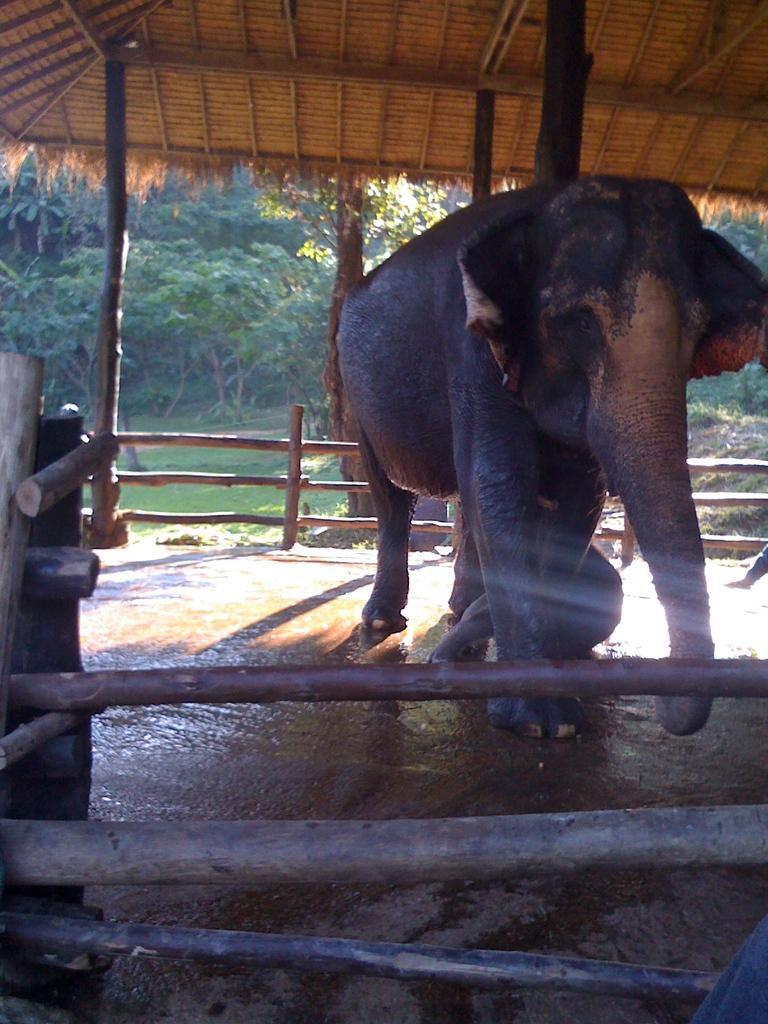What animal is on the ground in the image? There is an elephant on the ground in the image. What can be seen in the background of the image? There is a group of wood poles, a shed, a group of trees, and grass visible in the background of the image. What type of weather can be seen in the harbor in the image? There is no harbor or ocean present in the image, so it is not possible to determine the weather conditions. 